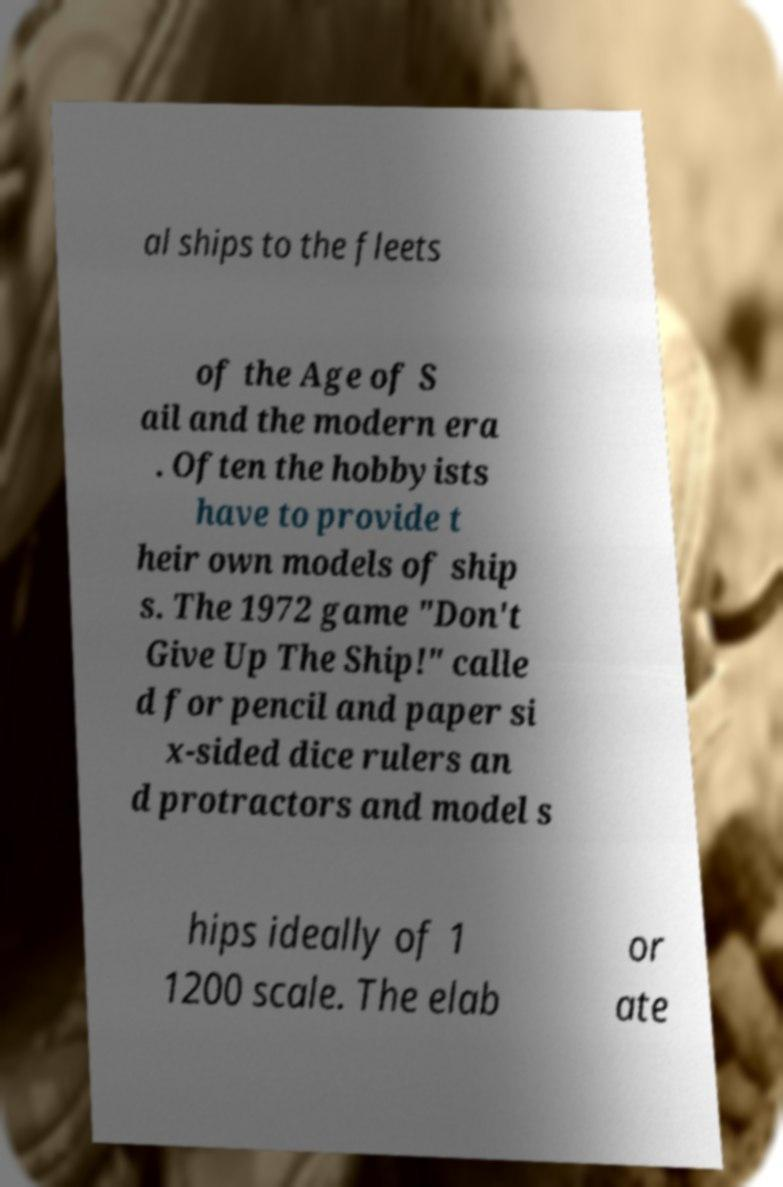What messages or text are displayed in this image? I need them in a readable, typed format. al ships to the fleets of the Age of S ail and the modern era . Often the hobbyists have to provide t heir own models of ship s. The 1972 game "Don't Give Up The Ship!" calle d for pencil and paper si x-sided dice rulers an d protractors and model s hips ideally of 1 1200 scale. The elab or ate 